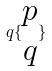Convert formula to latex. <formula><loc_0><loc_0><loc_500><loc_500>q \{ \begin{matrix} p \\ q \end{matrix} \}</formula> 